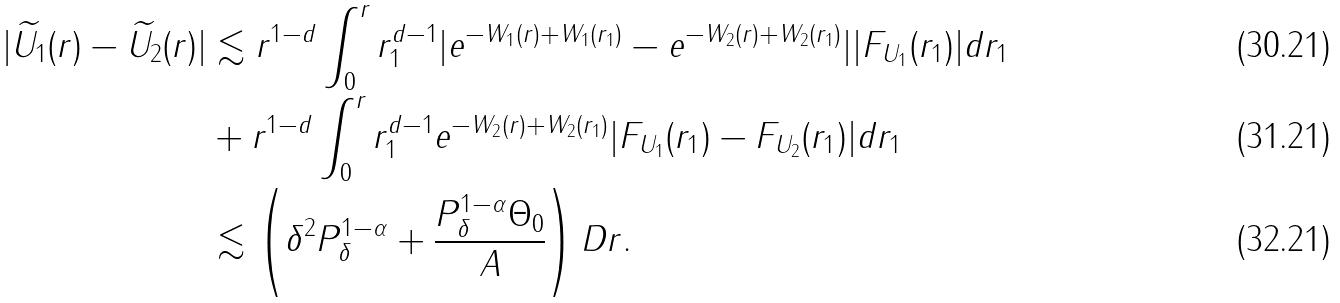Convert formula to latex. <formula><loc_0><loc_0><loc_500><loc_500>| \widetilde { U _ { 1 } } ( r ) - \widetilde { U _ { 2 } } ( r ) | & \lesssim r ^ { 1 - d } \int _ { 0 } ^ { r } r _ { 1 } ^ { d - 1 } | e ^ { - W _ { 1 } ( r ) + W _ { 1 } ( r _ { 1 } ) } - e ^ { - W _ { 2 } ( r ) + W _ { 2 } ( r _ { 1 } ) } | | F _ { U _ { 1 } } ( r _ { 1 } ) | d r _ { 1 } \\ & + r ^ { 1 - d } \int _ { 0 } ^ { r } r _ { 1 } ^ { d - 1 } e ^ { - W _ { 2 } ( r ) + W _ { 2 } ( r _ { 1 } ) } | F _ { U _ { 1 } } ( r _ { 1 } ) - F _ { U _ { 2 } } ( r _ { 1 } ) | d r _ { 1 } \\ & \lesssim \left ( \delta ^ { 2 } P _ { \delta } ^ { 1 - \alpha } + \frac { P _ { \delta } ^ { 1 - \alpha } \Theta _ { 0 } } { A } \right ) D r .</formula> 